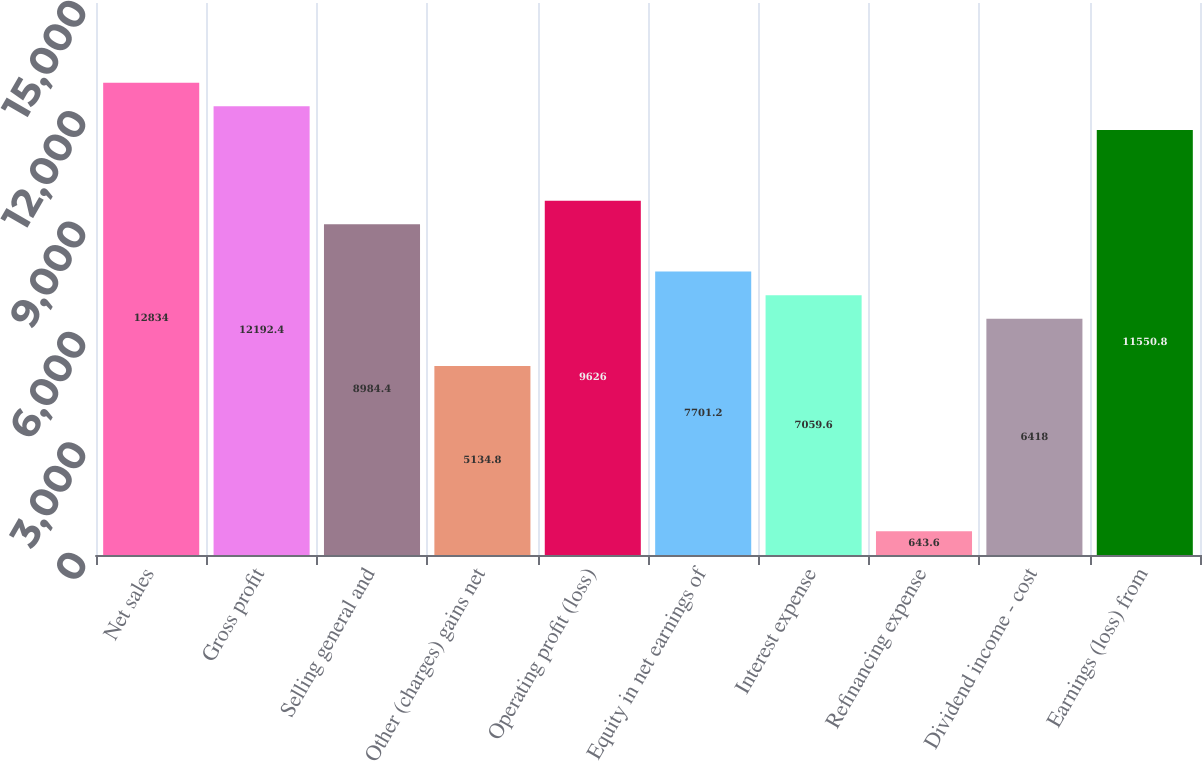<chart> <loc_0><loc_0><loc_500><loc_500><bar_chart><fcel>Net sales<fcel>Gross profit<fcel>Selling general and<fcel>Other (charges) gains net<fcel>Operating profit (loss)<fcel>Equity in net earnings of<fcel>Interest expense<fcel>Refinancing expense<fcel>Dividend income - cost<fcel>Earnings (loss) from<nl><fcel>12834<fcel>12192.4<fcel>8984.4<fcel>5134.8<fcel>9626<fcel>7701.2<fcel>7059.6<fcel>643.6<fcel>6418<fcel>11550.8<nl></chart> 